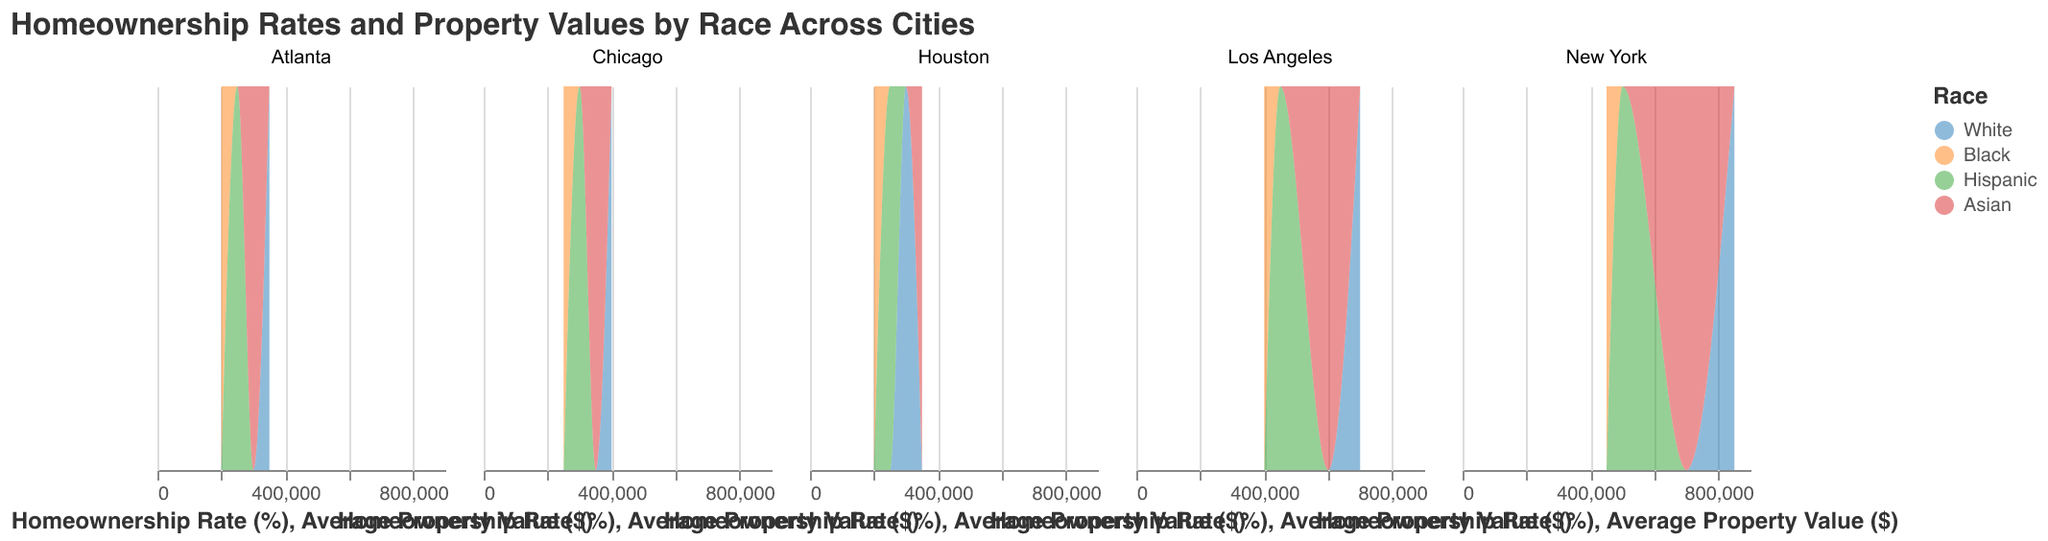What's the title of the figure? The title of the figure is displayed at the top and it reads "Homeownership Rates and Property Values by Race Across Cities".
Answer: Homeownership Rates and Property Values by Race Across Cities What colors are used to represent different races in the figure? The colors used to represent different races are: White is blue, Black is orange, Hispanic is green, and Asian is red.
Answer: Blue, Orange, Green, Red Which city has the highest homeownership rate for Black individuals? From the plots, Atlanta has the highest homeownership rate for Black individuals, reaching 50%.
Answer: Atlanta In which city do Hispanic homeowners have the lowest average property value? Examining the figures, the lowest average property value for Hispanic homeowners is seen in Houston, at $250,000.
Answer: Houston Compare the homeownership rates for Asian individuals in Chicago and Los Angeles. Which city has a higher rate? In Chicago, the homeownership rate for Asians is 50%, while in Los Angeles it is 45%. Hence, Chicago has a higher homeownership rate for Asians.
Answer: Chicago Which race has the highest average property value in New York? By looking at the plot for New York, the White race has the highest average property value at $850,000.
Answer: White Compare the homeownership rates between White and Hispanic individuals in Houston. What is the difference? The homeownership rate for Whites in Houston is 65%, while for Hispanics it is 45%. The difference is 20 percentage points.
Answer: 20% Which city has the lowest average property value for Black individuals? From the figure, Houston has the lowest average property value for Black individuals, which is $200,000.
Answer: Houston What is the combined average property value of Black homeowners in New York and Los Angeles? The average property value for Black homeowners in New York is $450,000 and in Los Angeles it is $400,000. The combined value is $450,000 + $400,000 = $850,000.
Answer: $850,000 In which city do White homeowners have the highest homeownership rate? The plot shows that White homeowners in Atlanta have the highest homeownership rate, which is 70%.
Answer: Atlanta 